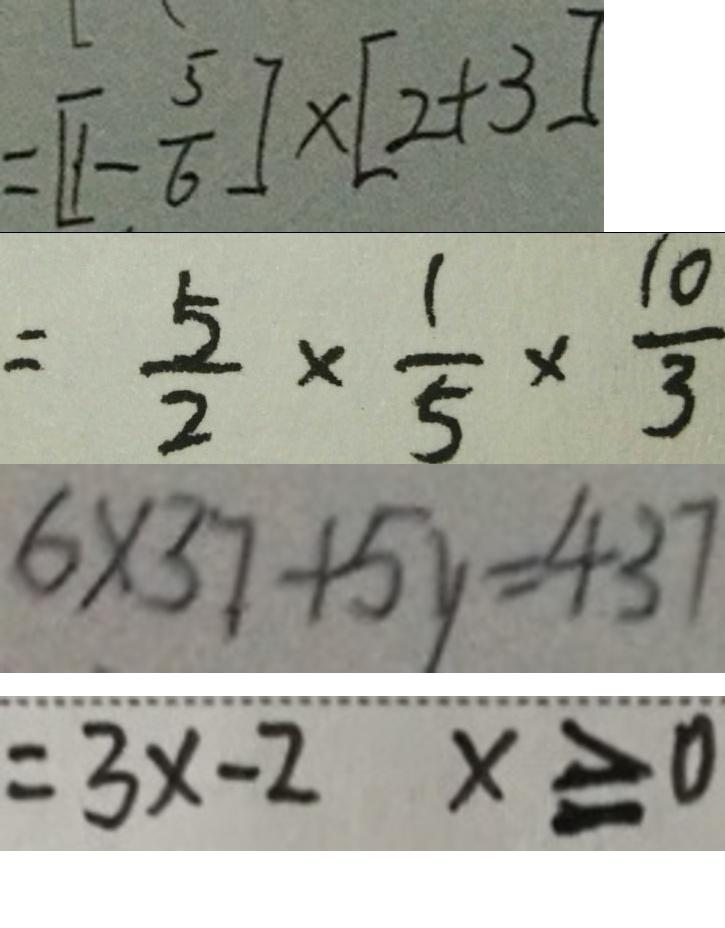<formula> <loc_0><loc_0><loc_500><loc_500>= [ 1 - \frac { 5 } { 6 } ] \times [ 2 + 3 ] 
 = \frac { 5 } { 2 } \times \frac { 1 } { 5 } \times \frac { 1 0 } { 3 } 
 6 \times 3 7 + 5 y = 4 3 7 
 = 3 x - 2 x \geq 0</formula> 